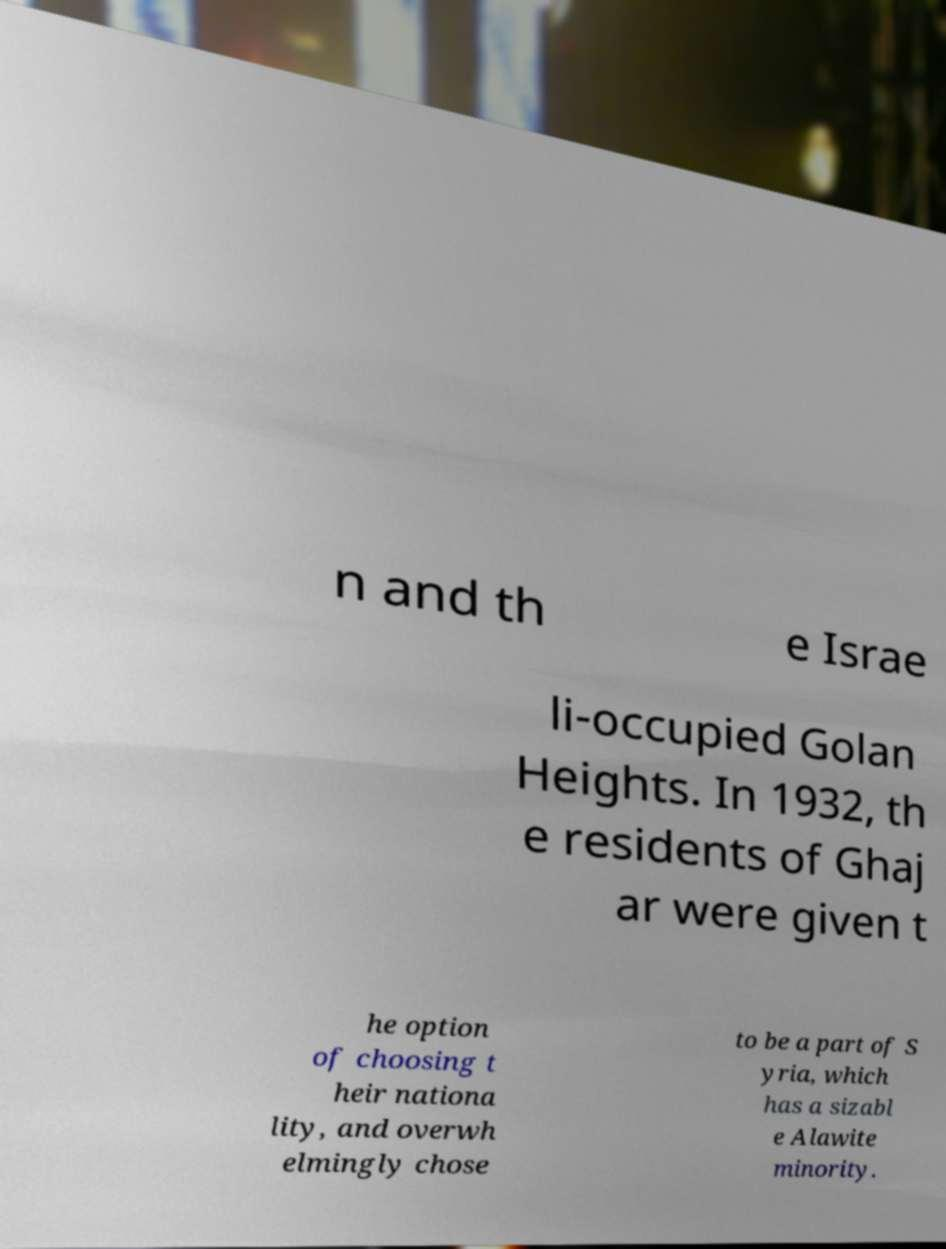Can you accurately transcribe the text from the provided image for me? n and th e Israe li-occupied Golan Heights. In 1932, th e residents of Ghaj ar were given t he option of choosing t heir nationa lity, and overwh elmingly chose to be a part of S yria, which has a sizabl e Alawite minority. 